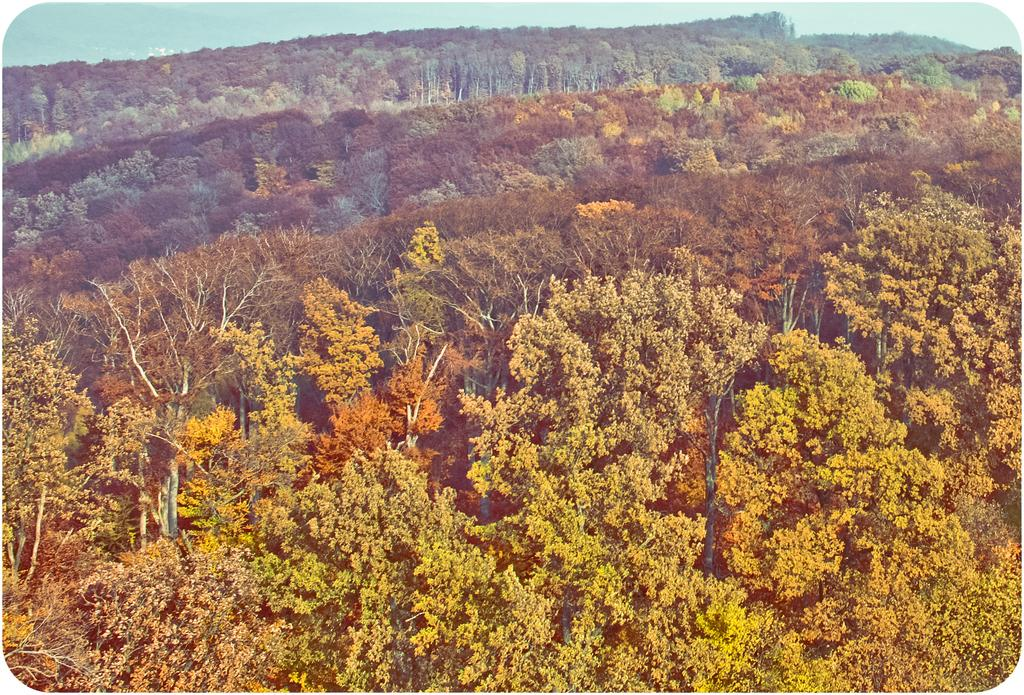What is the primary feature of the image? There is a lot of greenery in the image. Can you describe the type of vegetation present in the image? There are plenty of trees in the image. What is the chance of finding an office in the image? There is no mention of an office in the image, as it primarily features greenery and trees. Is there a zipper visible in the image? There is no zipper present in the image; it primarily features greenery and trees. 